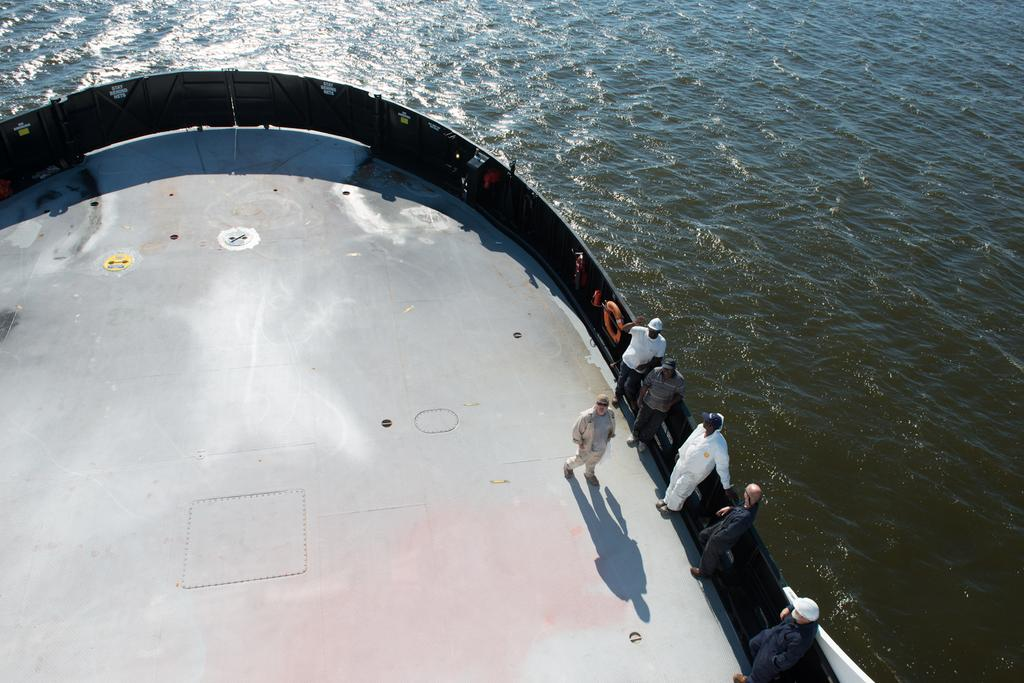Who or what can be seen in the image? There are people in the image. Where are the people located? The people are standing on a ship. What body of water is the ship on? The ship is on a river. What type of glass is being used to capture the steam in the image? There is no glass or steam present in the image; it features people standing on a ship on a river. 